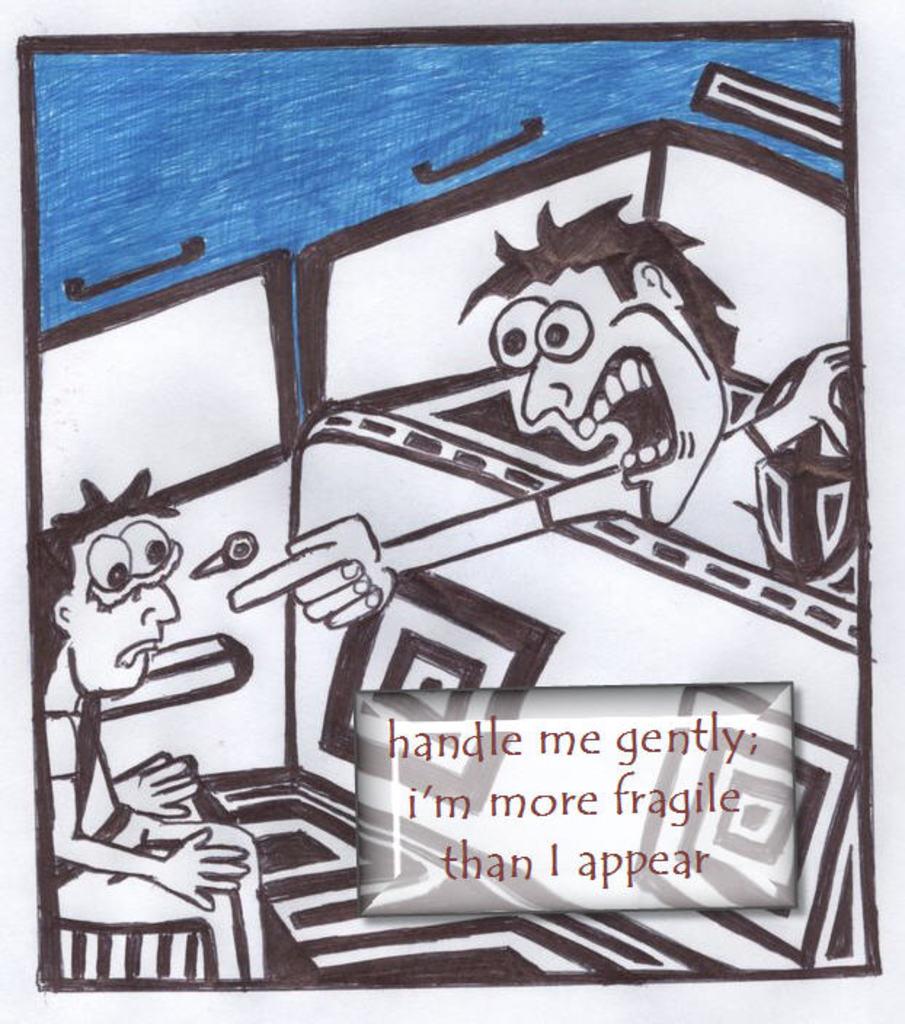What does the cartoon say?
Ensure brevity in your answer.  Handle me gently; i'm more fragile than i appear. What word comes after "more"?
Keep it short and to the point. Fragile. 